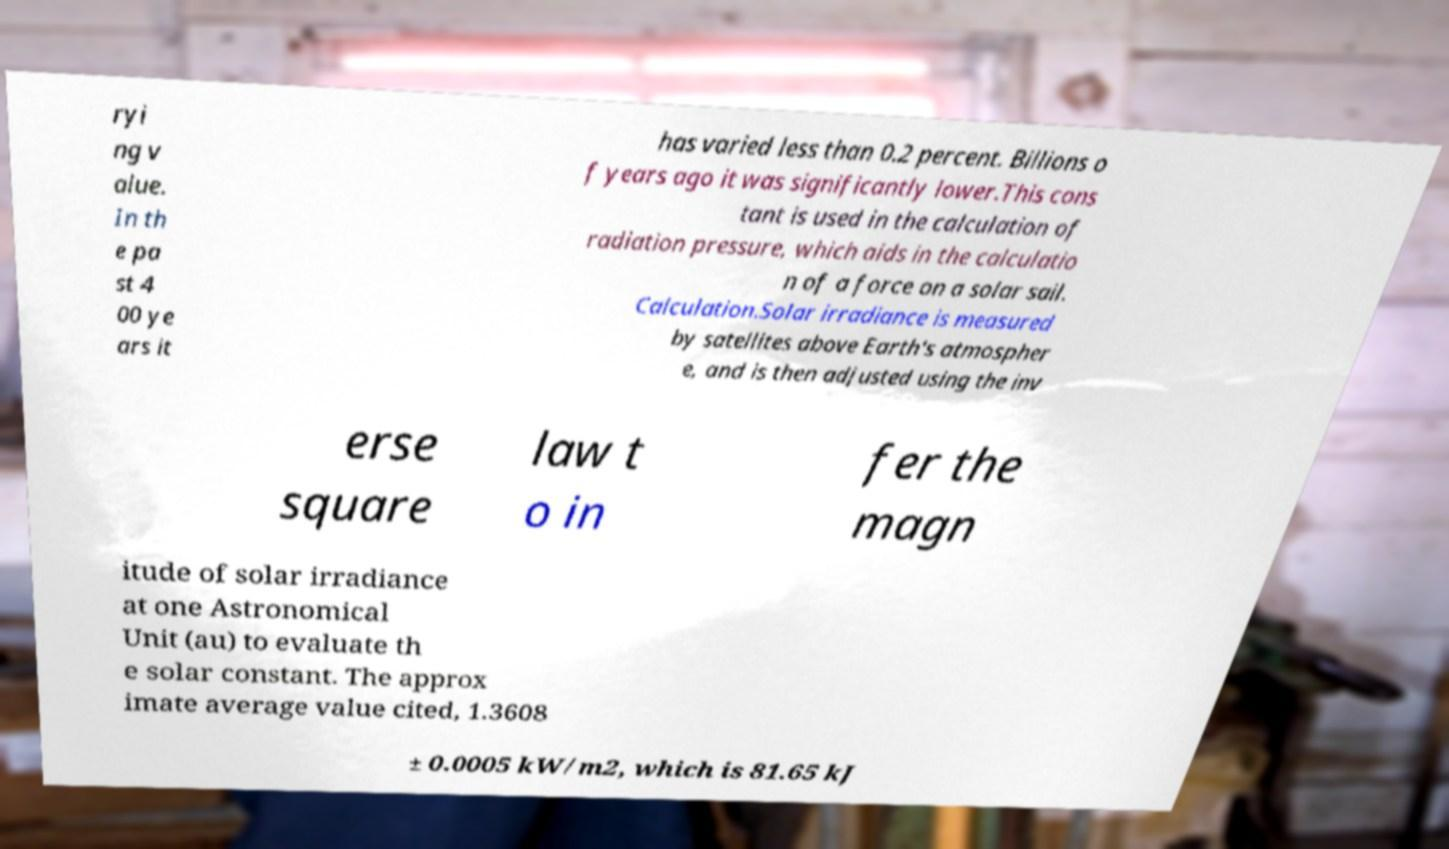For documentation purposes, I need the text within this image transcribed. Could you provide that? ryi ng v alue. In th e pa st 4 00 ye ars it has varied less than 0.2 percent. Billions o f years ago it was significantly lower.This cons tant is used in the calculation of radiation pressure, which aids in the calculatio n of a force on a solar sail. Calculation.Solar irradiance is measured by satellites above Earth's atmospher e, and is then adjusted using the inv erse square law t o in fer the magn itude of solar irradiance at one Astronomical Unit (au) to evaluate th e solar constant. The approx imate average value cited, 1.3608 ± 0.0005 kW/m2, which is 81.65 kJ 